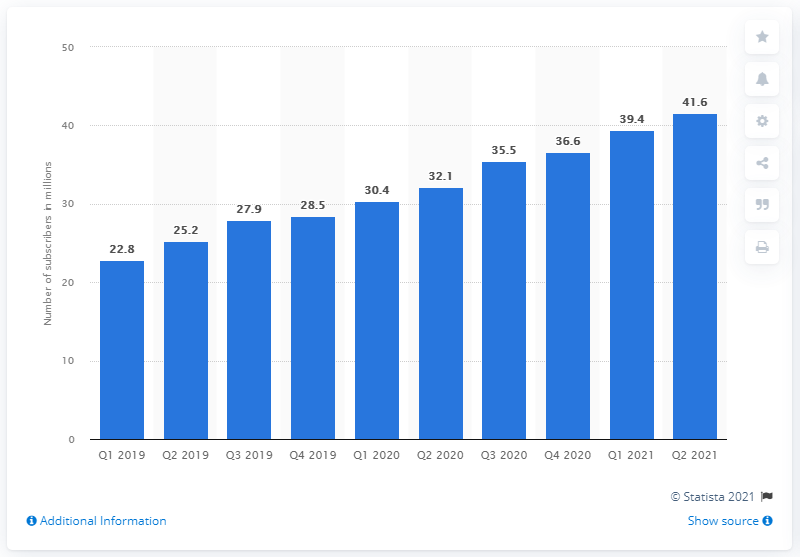Identify some key points in this picture. Hulu had 41.6 paid subscribers in the second quarter of 2021. In the corresponding quarter of the previous fiscal year, Hulu had 32.1 paid subscribers. 